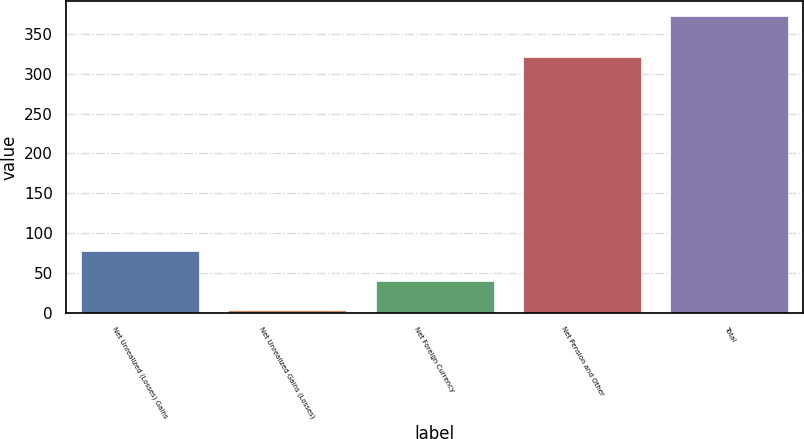Convert chart. <chart><loc_0><loc_0><loc_500><loc_500><bar_chart><fcel>Net Unrealized (Losses) Gains<fcel>Net Unrealized Gains (Losses)<fcel>Net Foreign Currency<fcel>Net Pension and Other<fcel>Total<nl><fcel>76.94<fcel>3<fcel>39.97<fcel>321.1<fcel>372.7<nl></chart> 